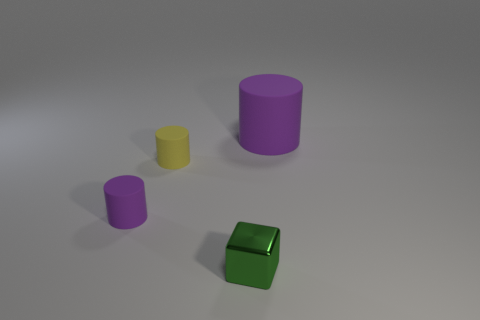What number of tiny green metallic blocks are to the left of the tiny purple cylinder? There are no tiny green metallic blocks to the left of the tiny purple cylinder in the image. Instead, directly to the left of the purple cylinder, we see a smaller yellow cylinder. The solitary green metallic block is located separately and in front of the purple cylinder. 